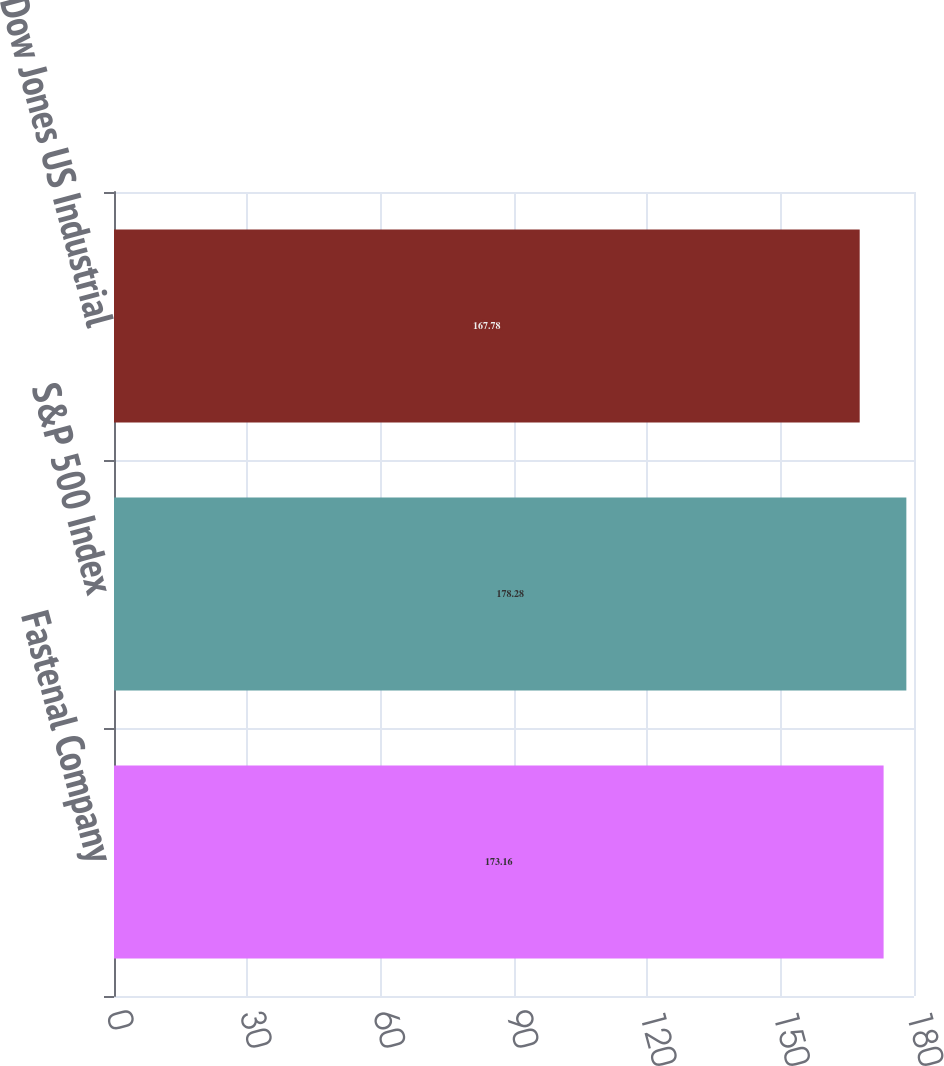Convert chart. <chart><loc_0><loc_0><loc_500><loc_500><bar_chart><fcel>Fastenal Company<fcel>S&P 500 Index<fcel>Dow Jones US Industrial<nl><fcel>173.16<fcel>178.28<fcel>167.78<nl></chart> 